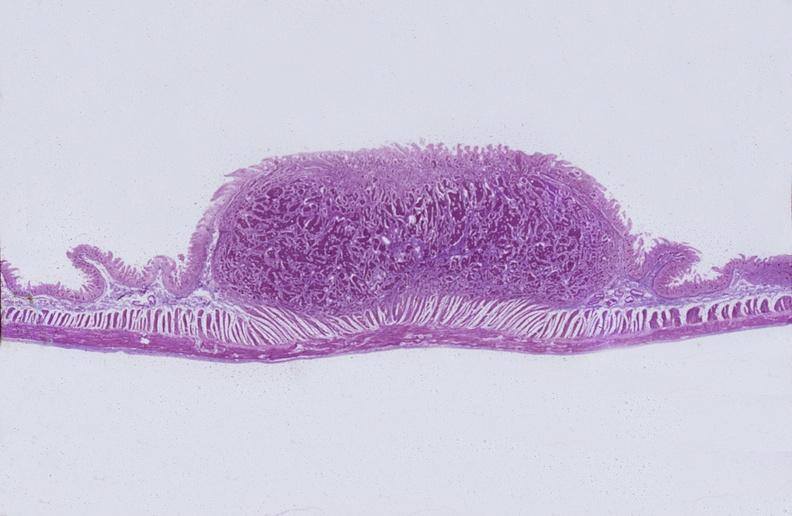what is present?
Answer the question using a single word or phrase. Gastrointestinal 